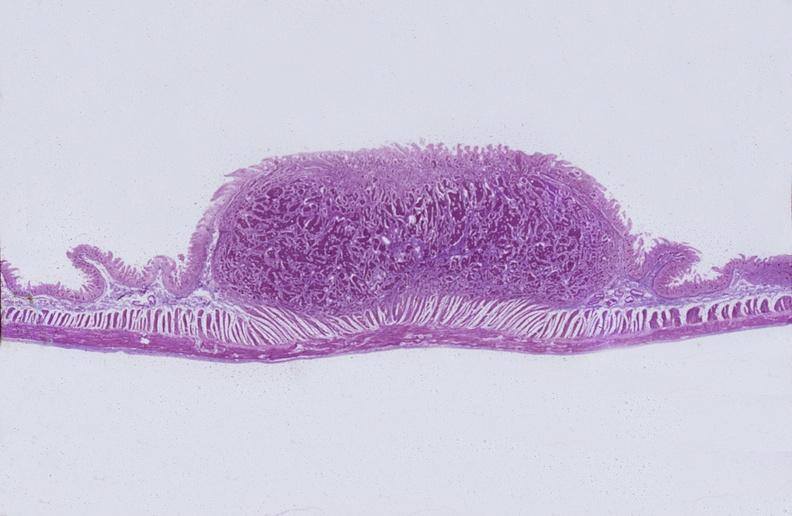what is present?
Answer the question using a single word or phrase. Gastrointestinal 